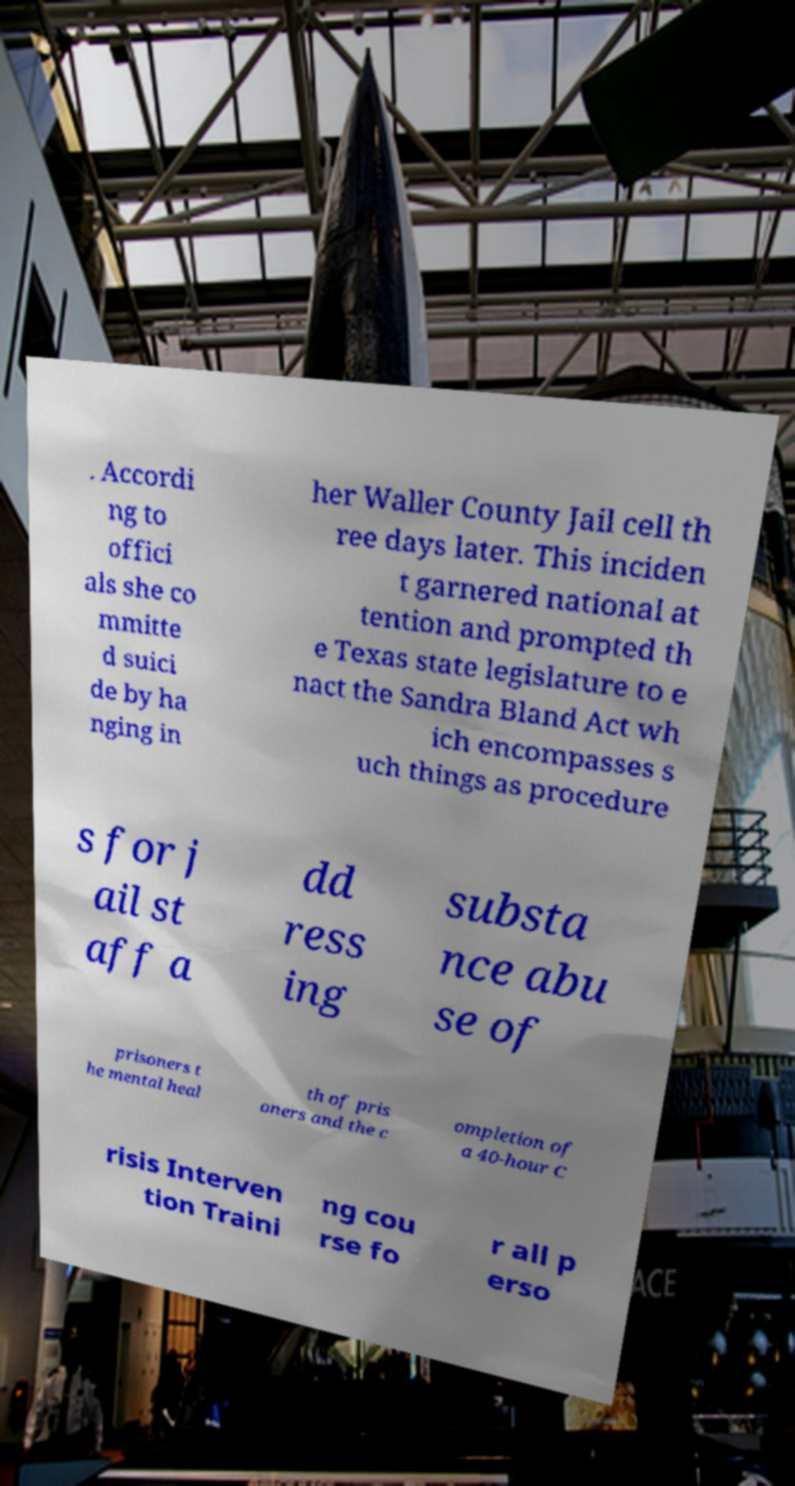For documentation purposes, I need the text within this image transcribed. Could you provide that? . Accordi ng to offici als she co mmitte d suici de by ha nging in her Waller County Jail cell th ree days later. This inciden t garnered national at tention and prompted th e Texas state legislature to e nact the Sandra Bland Act wh ich encompasses s uch things as procedure s for j ail st aff a dd ress ing substa nce abu se of prisoners t he mental heal th of pris oners and the c ompletion of a 40-hour C risis Interven tion Traini ng cou rse fo r all p erso 